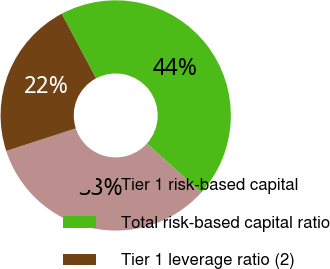Convert chart to OTSL. <chart><loc_0><loc_0><loc_500><loc_500><pie_chart><fcel>Tier 1 risk-based capital<fcel>Total risk-based capital ratio<fcel>Tier 1 leverage ratio (2)<nl><fcel>33.33%<fcel>44.44%<fcel>22.22%<nl></chart> 